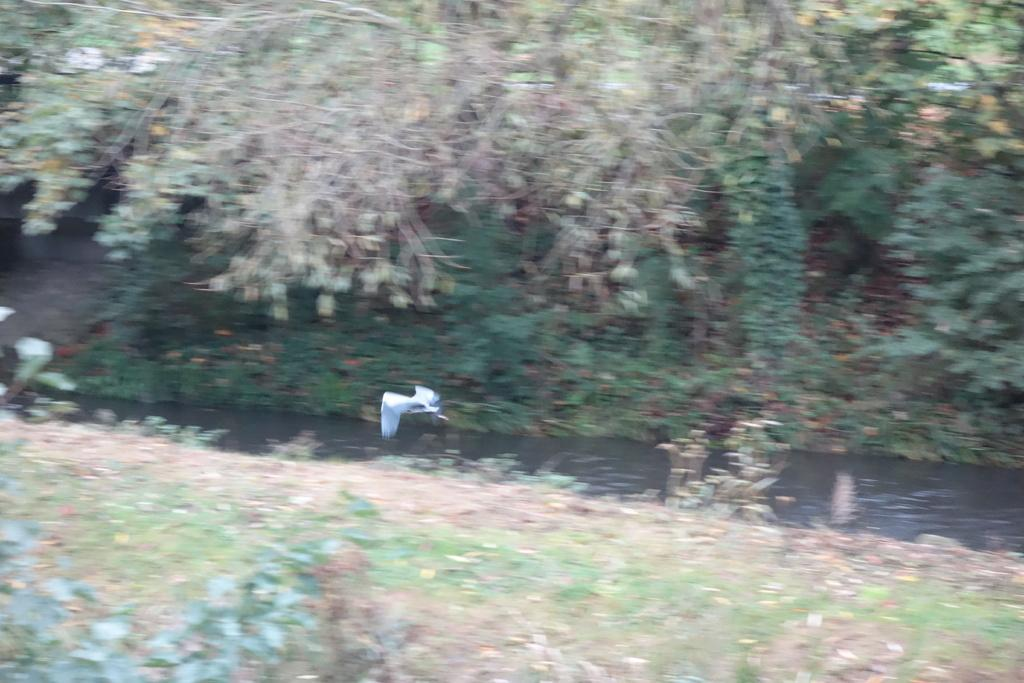What is the bird in the image doing? A bird is flying in the air in the image. What type of vegetation can be seen in the image? There are plants and trees visible in the image. What natural element is visible in the image? There is water visible in the image. What nation is the bird representing in the image? There is no indication in the image that the bird represents any nation. What type of wrench can be seen in the image? There is no wrench present in the image. 